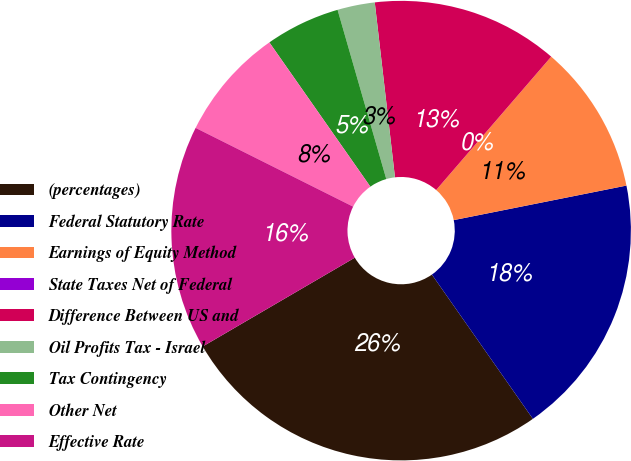Convert chart. <chart><loc_0><loc_0><loc_500><loc_500><pie_chart><fcel>(percentages)<fcel>Federal Statutory Rate<fcel>Earnings of Equity Method<fcel>State Taxes Net of Federal<fcel>Difference Between US and<fcel>Oil Profits Tax - Israel<fcel>Tax Contingency<fcel>Other Net<fcel>Effective Rate<nl><fcel>26.31%<fcel>18.42%<fcel>10.53%<fcel>0.0%<fcel>13.16%<fcel>2.63%<fcel>5.26%<fcel>7.9%<fcel>15.79%<nl></chart> 